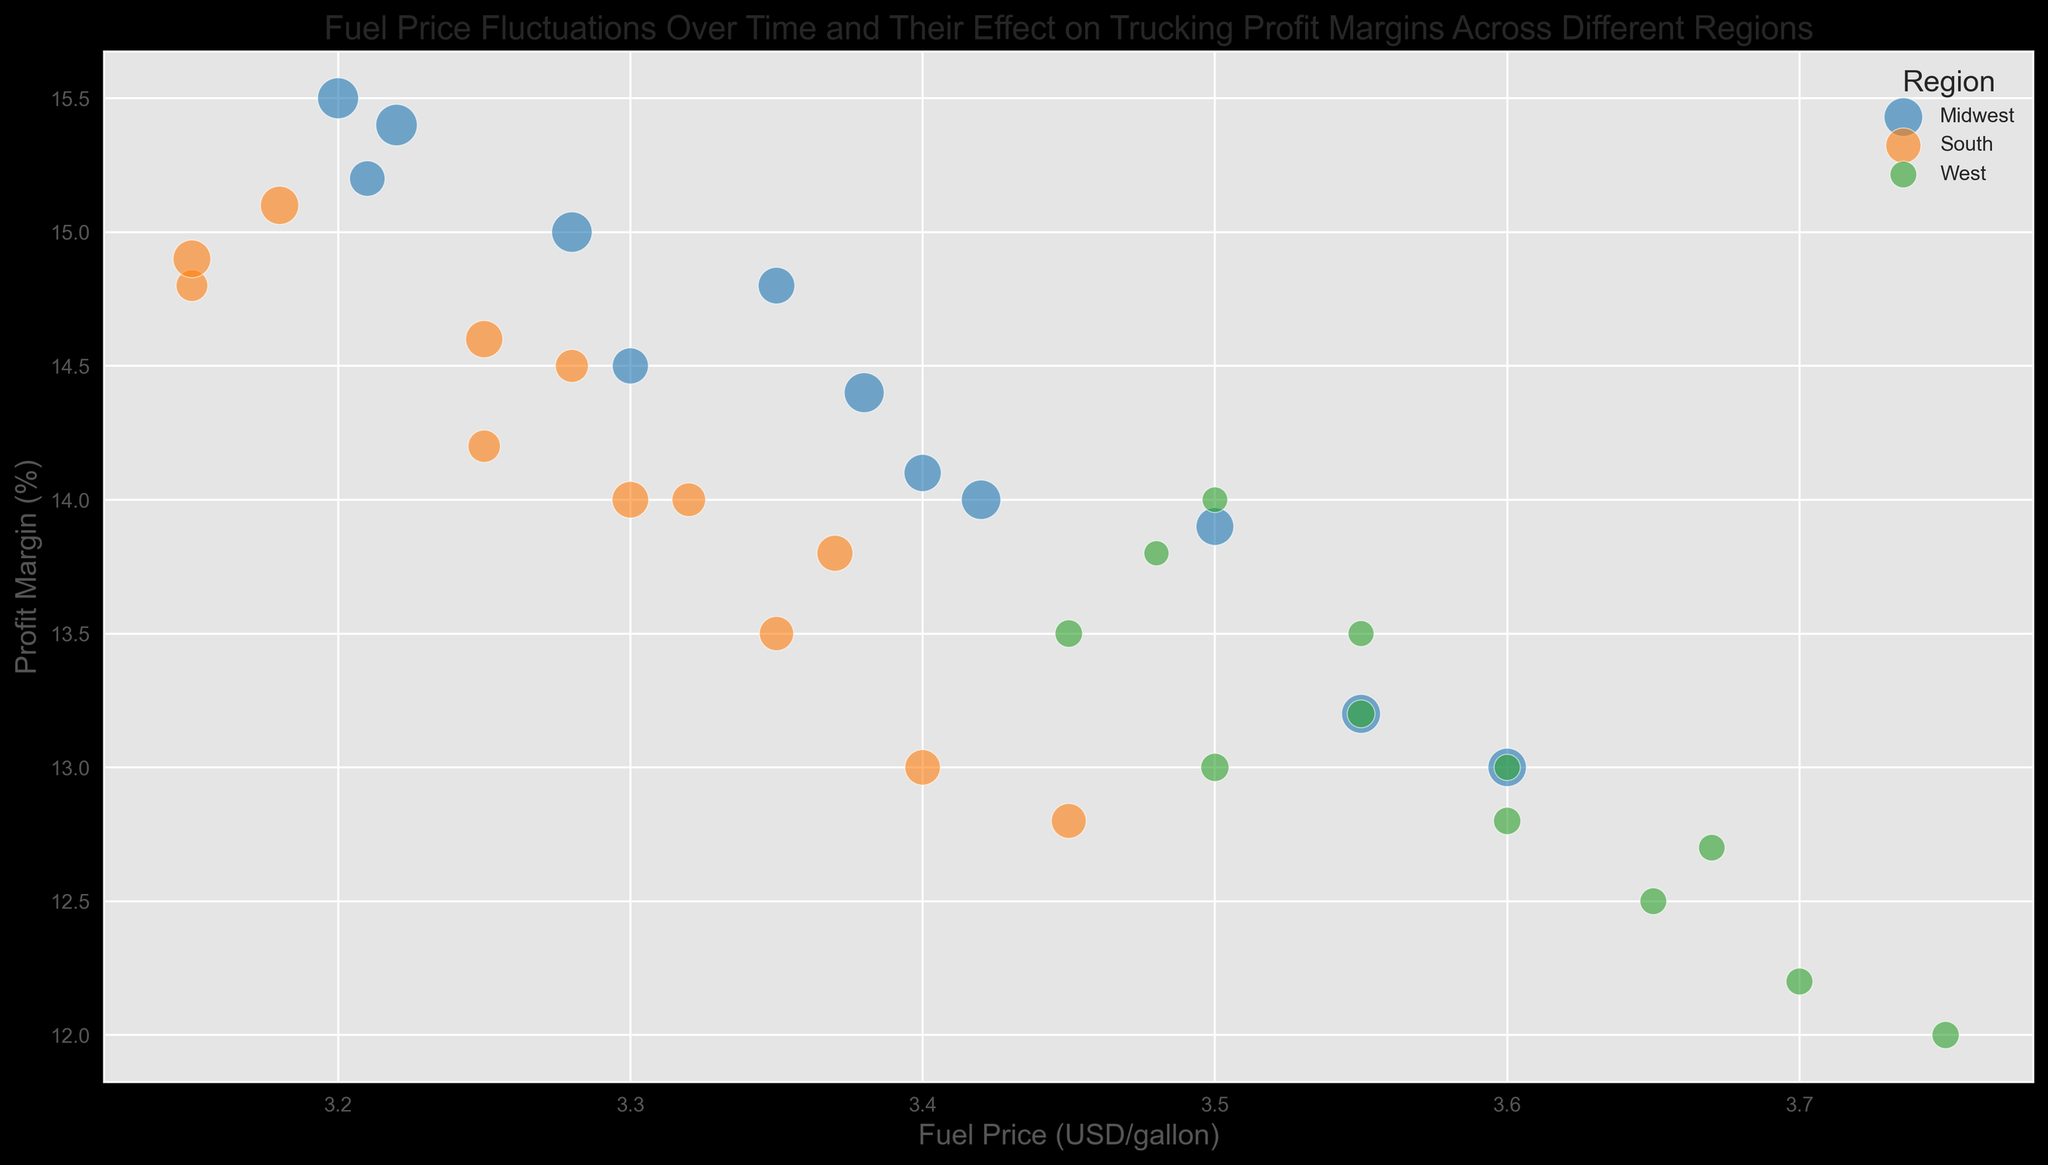What's the overall trend of profit margins as fuel prices increase? The plot shows that as fuel prices increase (x-axis), the profit margins (y-axis) tend to decrease across all regions. This trend is visually apparent as points generally slope downwards from left to right.
Answer: Decrease Which region had the highest profit margin when the fuel price was around $3.50? Locate the points where the x-axis (fuel price) is around $3.50. Among these, the highest positioned point on the y-axis corresponds to the Midwest region. This is indicated by its blue color.
Answer: Midwest How do profit margins in the Midwest compare to those in the West for the same fuel price range? Compare blue and green points vertically aligned at the same x-axis positions. For almost all x-values, blue points (Midwest) are higher than green points (West), indicating better profit margins in the Midwest.
Answer: Midwest margins are higher What is the size trend of bubbles for Midwest data points over time? The size of bubbles represents the volume of trucks. As time progresses from left to right (assuming fuel prices generally rise over time), bubbles for the Midwest (blue) get larger, indicating an increasing volume of trucks.
Answer: Increase What's the average profit margin for the Midwest during high fuel prices above $3.60? Identify blue bubbles (Midwest) where the x-axis value is above 3.60. Read corresponding y-values: (13.0, 13.2, 14.0, 14.4, 15.0, 15.5, 15.4). Calculate the average: (13.0+13.2+14.0+14.4+15.0+15.5+15.4)/7.
Answer: 14.36 Compare the size of bubbles for the Midwest and the South for May 2022. Locate the bubbles at x-axis (fuel price) for May 2022, around 3.50 for Midwest (blue) and 3.35 for South (orange). Compare the sizes directly: the Midwest bubble is noticeably larger than the South bubble.
Answer: Midwest is larger Which region has the smallest decrease in profit margin as fuel prices increase from January to December in 2022? Observe the slope of points. Compare blue (Midwest), orange (South), and green (West) series from left to right. Midwest (blue) has a *relatively* gentle downward slope, indicating the smallest decrease.
Answer: Midwest 